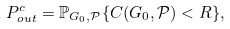Convert formula to latex. <formula><loc_0><loc_0><loc_500><loc_500>P _ { o u t } ^ { c } = \mathbb { P } _ { G _ { 0 } , \mathcal { P } } \{ C ( G _ { 0 } , \mathcal { P } ) < R \} ,</formula> 